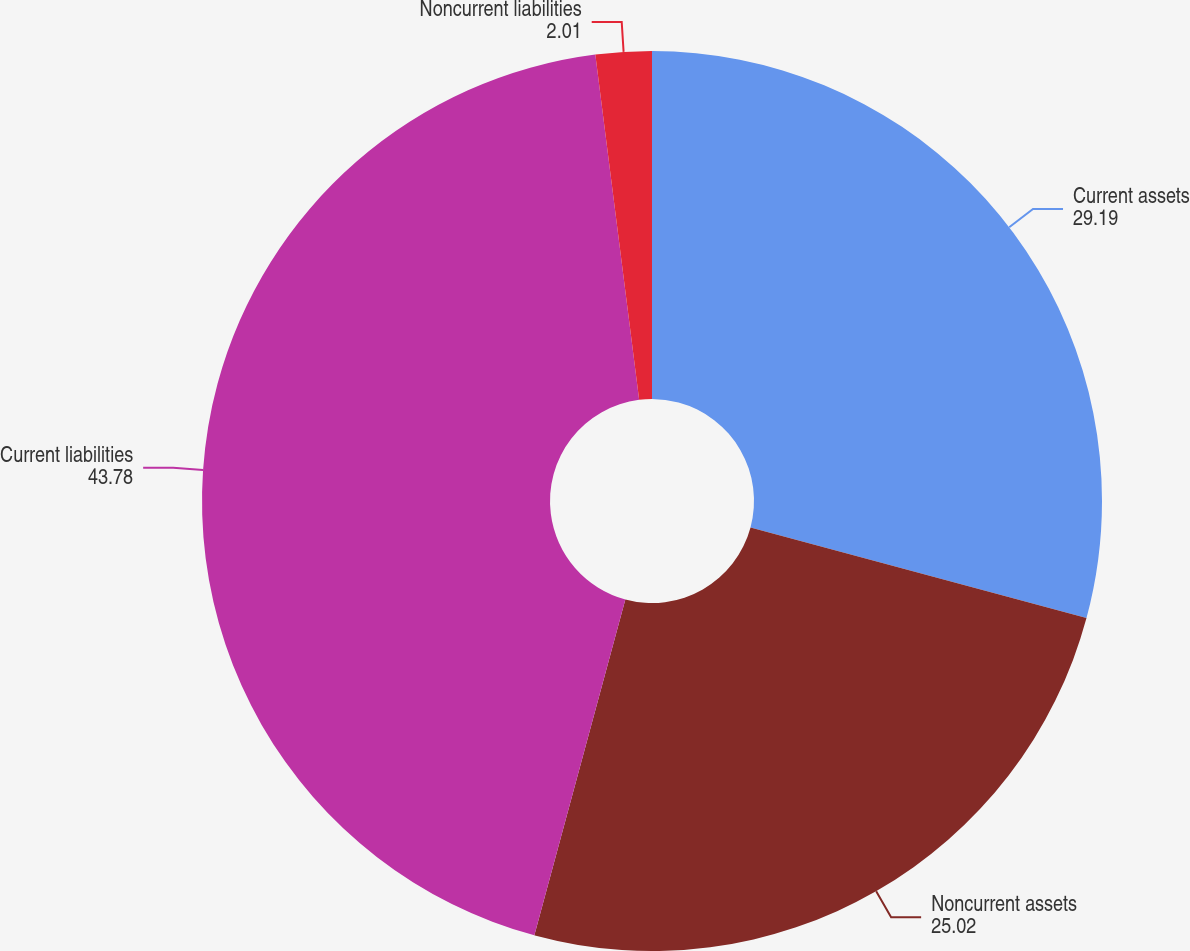Convert chart. <chart><loc_0><loc_0><loc_500><loc_500><pie_chart><fcel>Current assets<fcel>Noncurrent assets<fcel>Current liabilities<fcel>Noncurrent liabilities<nl><fcel>29.19%<fcel>25.02%<fcel>43.78%<fcel>2.01%<nl></chart> 